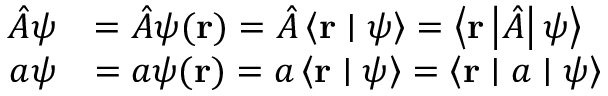<formula> <loc_0><loc_0><loc_500><loc_500>{ \begin{array} { r l } { { \hat { A } } \psi } & { = { \hat { A } } \psi ( r ) = { \hat { A } } \left \langle r | \psi \right \rangle = \left \langle r \left | { \hat { A } } \right | \psi \right \rangle } \\ { a \psi } & { = a \psi ( r ) = a \left \langle r | \psi \right \rangle = \left \langle r | a | \psi \right \rangle } \end{array} }</formula> 